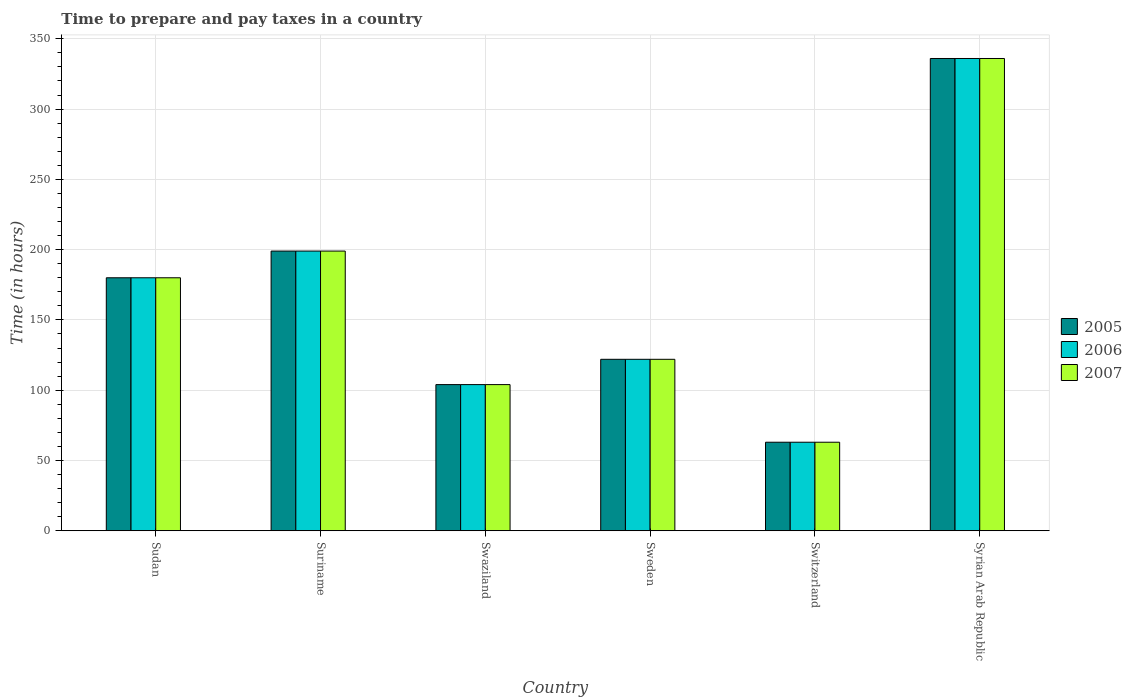Are the number of bars on each tick of the X-axis equal?
Offer a very short reply. Yes. What is the label of the 3rd group of bars from the left?
Provide a short and direct response. Swaziland. Across all countries, what is the maximum number of hours required to prepare and pay taxes in 2005?
Your response must be concise. 336. In which country was the number of hours required to prepare and pay taxes in 2007 maximum?
Offer a terse response. Syrian Arab Republic. In which country was the number of hours required to prepare and pay taxes in 2007 minimum?
Make the answer very short. Switzerland. What is the total number of hours required to prepare and pay taxes in 2006 in the graph?
Give a very brief answer. 1004. What is the difference between the number of hours required to prepare and pay taxes in 2007 in Sudan and that in Sweden?
Provide a succinct answer. 58. What is the difference between the number of hours required to prepare and pay taxes in 2005 in Swaziland and the number of hours required to prepare and pay taxes in 2007 in Suriname?
Ensure brevity in your answer.  -95. What is the average number of hours required to prepare and pay taxes in 2006 per country?
Provide a succinct answer. 167.33. In how many countries, is the number of hours required to prepare and pay taxes in 2007 greater than 340 hours?
Your answer should be compact. 0. What is the ratio of the number of hours required to prepare and pay taxes in 2005 in Sudan to that in Syrian Arab Republic?
Give a very brief answer. 0.54. Is the number of hours required to prepare and pay taxes in 2007 in Sweden less than that in Syrian Arab Republic?
Provide a succinct answer. Yes. What is the difference between the highest and the second highest number of hours required to prepare and pay taxes in 2005?
Offer a terse response. 156. What is the difference between the highest and the lowest number of hours required to prepare and pay taxes in 2006?
Keep it short and to the point. 273. In how many countries, is the number of hours required to prepare and pay taxes in 2005 greater than the average number of hours required to prepare and pay taxes in 2005 taken over all countries?
Your response must be concise. 3. What does the 3rd bar from the left in Sweden represents?
Ensure brevity in your answer.  2007. What does the 1st bar from the right in Swaziland represents?
Offer a terse response. 2007. Is it the case that in every country, the sum of the number of hours required to prepare and pay taxes in 2006 and number of hours required to prepare and pay taxes in 2007 is greater than the number of hours required to prepare and pay taxes in 2005?
Your answer should be very brief. Yes. How many bars are there?
Make the answer very short. 18. Are all the bars in the graph horizontal?
Give a very brief answer. No. How many countries are there in the graph?
Offer a very short reply. 6. Are the values on the major ticks of Y-axis written in scientific E-notation?
Provide a succinct answer. No. Does the graph contain any zero values?
Provide a short and direct response. No. Where does the legend appear in the graph?
Ensure brevity in your answer.  Center right. How many legend labels are there?
Offer a very short reply. 3. What is the title of the graph?
Provide a succinct answer. Time to prepare and pay taxes in a country. What is the label or title of the Y-axis?
Provide a succinct answer. Time (in hours). What is the Time (in hours) of 2005 in Sudan?
Ensure brevity in your answer.  180. What is the Time (in hours) in 2006 in Sudan?
Your answer should be very brief. 180. What is the Time (in hours) of 2007 in Sudan?
Provide a short and direct response. 180. What is the Time (in hours) of 2005 in Suriname?
Give a very brief answer. 199. What is the Time (in hours) of 2006 in Suriname?
Provide a succinct answer. 199. What is the Time (in hours) in 2007 in Suriname?
Give a very brief answer. 199. What is the Time (in hours) in 2005 in Swaziland?
Keep it short and to the point. 104. What is the Time (in hours) in 2006 in Swaziland?
Give a very brief answer. 104. What is the Time (in hours) of 2007 in Swaziland?
Offer a terse response. 104. What is the Time (in hours) in 2005 in Sweden?
Your answer should be very brief. 122. What is the Time (in hours) of 2006 in Sweden?
Keep it short and to the point. 122. What is the Time (in hours) in 2007 in Sweden?
Your answer should be very brief. 122. What is the Time (in hours) in 2005 in Switzerland?
Provide a succinct answer. 63. What is the Time (in hours) in 2007 in Switzerland?
Offer a very short reply. 63. What is the Time (in hours) of 2005 in Syrian Arab Republic?
Offer a terse response. 336. What is the Time (in hours) in 2006 in Syrian Arab Republic?
Provide a succinct answer. 336. What is the Time (in hours) in 2007 in Syrian Arab Republic?
Offer a terse response. 336. Across all countries, what is the maximum Time (in hours) of 2005?
Make the answer very short. 336. Across all countries, what is the maximum Time (in hours) of 2006?
Offer a very short reply. 336. Across all countries, what is the maximum Time (in hours) in 2007?
Make the answer very short. 336. Across all countries, what is the minimum Time (in hours) in 2005?
Give a very brief answer. 63. Across all countries, what is the minimum Time (in hours) in 2006?
Offer a very short reply. 63. Across all countries, what is the minimum Time (in hours) in 2007?
Offer a terse response. 63. What is the total Time (in hours) of 2005 in the graph?
Give a very brief answer. 1004. What is the total Time (in hours) of 2006 in the graph?
Keep it short and to the point. 1004. What is the total Time (in hours) in 2007 in the graph?
Ensure brevity in your answer.  1004. What is the difference between the Time (in hours) of 2006 in Sudan and that in Suriname?
Keep it short and to the point. -19. What is the difference between the Time (in hours) in 2005 in Sudan and that in Sweden?
Keep it short and to the point. 58. What is the difference between the Time (in hours) in 2007 in Sudan and that in Sweden?
Your answer should be very brief. 58. What is the difference between the Time (in hours) of 2005 in Sudan and that in Switzerland?
Your response must be concise. 117. What is the difference between the Time (in hours) in 2006 in Sudan and that in Switzerland?
Your response must be concise. 117. What is the difference between the Time (in hours) of 2007 in Sudan and that in Switzerland?
Your response must be concise. 117. What is the difference between the Time (in hours) of 2005 in Sudan and that in Syrian Arab Republic?
Offer a terse response. -156. What is the difference between the Time (in hours) in 2006 in Sudan and that in Syrian Arab Republic?
Ensure brevity in your answer.  -156. What is the difference between the Time (in hours) of 2007 in Sudan and that in Syrian Arab Republic?
Give a very brief answer. -156. What is the difference between the Time (in hours) in 2006 in Suriname and that in Swaziland?
Your answer should be compact. 95. What is the difference between the Time (in hours) in 2005 in Suriname and that in Sweden?
Provide a short and direct response. 77. What is the difference between the Time (in hours) in 2006 in Suriname and that in Sweden?
Provide a succinct answer. 77. What is the difference between the Time (in hours) in 2007 in Suriname and that in Sweden?
Give a very brief answer. 77. What is the difference between the Time (in hours) in 2005 in Suriname and that in Switzerland?
Provide a succinct answer. 136. What is the difference between the Time (in hours) of 2006 in Suriname and that in Switzerland?
Your answer should be compact. 136. What is the difference between the Time (in hours) of 2007 in Suriname and that in Switzerland?
Your response must be concise. 136. What is the difference between the Time (in hours) of 2005 in Suriname and that in Syrian Arab Republic?
Provide a short and direct response. -137. What is the difference between the Time (in hours) in 2006 in Suriname and that in Syrian Arab Republic?
Give a very brief answer. -137. What is the difference between the Time (in hours) of 2007 in Suriname and that in Syrian Arab Republic?
Provide a short and direct response. -137. What is the difference between the Time (in hours) of 2006 in Swaziland and that in Sweden?
Ensure brevity in your answer.  -18. What is the difference between the Time (in hours) of 2006 in Swaziland and that in Switzerland?
Give a very brief answer. 41. What is the difference between the Time (in hours) in 2007 in Swaziland and that in Switzerland?
Ensure brevity in your answer.  41. What is the difference between the Time (in hours) in 2005 in Swaziland and that in Syrian Arab Republic?
Provide a short and direct response. -232. What is the difference between the Time (in hours) in 2006 in Swaziland and that in Syrian Arab Republic?
Make the answer very short. -232. What is the difference between the Time (in hours) in 2007 in Swaziland and that in Syrian Arab Republic?
Your answer should be compact. -232. What is the difference between the Time (in hours) of 2005 in Sweden and that in Switzerland?
Give a very brief answer. 59. What is the difference between the Time (in hours) in 2005 in Sweden and that in Syrian Arab Republic?
Your answer should be compact. -214. What is the difference between the Time (in hours) in 2006 in Sweden and that in Syrian Arab Republic?
Your answer should be very brief. -214. What is the difference between the Time (in hours) of 2007 in Sweden and that in Syrian Arab Republic?
Make the answer very short. -214. What is the difference between the Time (in hours) of 2005 in Switzerland and that in Syrian Arab Republic?
Provide a short and direct response. -273. What is the difference between the Time (in hours) of 2006 in Switzerland and that in Syrian Arab Republic?
Provide a short and direct response. -273. What is the difference between the Time (in hours) in 2007 in Switzerland and that in Syrian Arab Republic?
Make the answer very short. -273. What is the difference between the Time (in hours) in 2005 in Sudan and the Time (in hours) in 2006 in Suriname?
Your response must be concise. -19. What is the difference between the Time (in hours) of 2006 in Sudan and the Time (in hours) of 2007 in Suriname?
Offer a very short reply. -19. What is the difference between the Time (in hours) in 2005 in Sudan and the Time (in hours) in 2006 in Swaziland?
Keep it short and to the point. 76. What is the difference between the Time (in hours) of 2005 in Sudan and the Time (in hours) of 2007 in Swaziland?
Give a very brief answer. 76. What is the difference between the Time (in hours) in 2006 in Sudan and the Time (in hours) in 2007 in Swaziland?
Offer a terse response. 76. What is the difference between the Time (in hours) in 2005 in Sudan and the Time (in hours) in 2007 in Sweden?
Keep it short and to the point. 58. What is the difference between the Time (in hours) in 2005 in Sudan and the Time (in hours) in 2006 in Switzerland?
Offer a terse response. 117. What is the difference between the Time (in hours) in 2005 in Sudan and the Time (in hours) in 2007 in Switzerland?
Keep it short and to the point. 117. What is the difference between the Time (in hours) in 2006 in Sudan and the Time (in hours) in 2007 in Switzerland?
Give a very brief answer. 117. What is the difference between the Time (in hours) in 2005 in Sudan and the Time (in hours) in 2006 in Syrian Arab Republic?
Offer a very short reply. -156. What is the difference between the Time (in hours) in 2005 in Sudan and the Time (in hours) in 2007 in Syrian Arab Republic?
Your answer should be very brief. -156. What is the difference between the Time (in hours) of 2006 in Sudan and the Time (in hours) of 2007 in Syrian Arab Republic?
Ensure brevity in your answer.  -156. What is the difference between the Time (in hours) of 2005 in Suriname and the Time (in hours) of 2006 in Swaziland?
Your answer should be very brief. 95. What is the difference between the Time (in hours) in 2006 in Suriname and the Time (in hours) in 2007 in Swaziland?
Your answer should be very brief. 95. What is the difference between the Time (in hours) of 2005 in Suriname and the Time (in hours) of 2007 in Sweden?
Your answer should be very brief. 77. What is the difference between the Time (in hours) in 2006 in Suriname and the Time (in hours) in 2007 in Sweden?
Ensure brevity in your answer.  77. What is the difference between the Time (in hours) in 2005 in Suriname and the Time (in hours) in 2006 in Switzerland?
Offer a very short reply. 136. What is the difference between the Time (in hours) of 2005 in Suriname and the Time (in hours) of 2007 in Switzerland?
Your response must be concise. 136. What is the difference between the Time (in hours) of 2006 in Suriname and the Time (in hours) of 2007 in Switzerland?
Provide a succinct answer. 136. What is the difference between the Time (in hours) of 2005 in Suriname and the Time (in hours) of 2006 in Syrian Arab Republic?
Your answer should be very brief. -137. What is the difference between the Time (in hours) in 2005 in Suriname and the Time (in hours) in 2007 in Syrian Arab Republic?
Your response must be concise. -137. What is the difference between the Time (in hours) in 2006 in Suriname and the Time (in hours) in 2007 in Syrian Arab Republic?
Your response must be concise. -137. What is the difference between the Time (in hours) of 2005 in Swaziland and the Time (in hours) of 2006 in Sweden?
Provide a short and direct response. -18. What is the difference between the Time (in hours) in 2005 in Swaziland and the Time (in hours) in 2007 in Sweden?
Provide a succinct answer. -18. What is the difference between the Time (in hours) of 2005 in Swaziland and the Time (in hours) of 2006 in Switzerland?
Provide a succinct answer. 41. What is the difference between the Time (in hours) of 2005 in Swaziland and the Time (in hours) of 2007 in Switzerland?
Offer a terse response. 41. What is the difference between the Time (in hours) of 2006 in Swaziland and the Time (in hours) of 2007 in Switzerland?
Offer a terse response. 41. What is the difference between the Time (in hours) of 2005 in Swaziland and the Time (in hours) of 2006 in Syrian Arab Republic?
Give a very brief answer. -232. What is the difference between the Time (in hours) of 2005 in Swaziland and the Time (in hours) of 2007 in Syrian Arab Republic?
Provide a short and direct response. -232. What is the difference between the Time (in hours) in 2006 in Swaziland and the Time (in hours) in 2007 in Syrian Arab Republic?
Keep it short and to the point. -232. What is the difference between the Time (in hours) of 2006 in Sweden and the Time (in hours) of 2007 in Switzerland?
Offer a very short reply. 59. What is the difference between the Time (in hours) in 2005 in Sweden and the Time (in hours) in 2006 in Syrian Arab Republic?
Offer a very short reply. -214. What is the difference between the Time (in hours) of 2005 in Sweden and the Time (in hours) of 2007 in Syrian Arab Republic?
Provide a short and direct response. -214. What is the difference between the Time (in hours) of 2006 in Sweden and the Time (in hours) of 2007 in Syrian Arab Republic?
Provide a short and direct response. -214. What is the difference between the Time (in hours) in 2005 in Switzerland and the Time (in hours) in 2006 in Syrian Arab Republic?
Offer a terse response. -273. What is the difference between the Time (in hours) of 2005 in Switzerland and the Time (in hours) of 2007 in Syrian Arab Republic?
Ensure brevity in your answer.  -273. What is the difference between the Time (in hours) of 2006 in Switzerland and the Time (in hours) of 2007 in Syrian Arab Republic?
Ensure brevity in your answer.  -273. What is the average Time (in hours) in 2005 per country?
Give a very brief answer. 167.33. What is the average Time (in hours) of 2006 per country?
Your answer should be very brief. 167.33. What is the average Time (in hours) in 2007 per country?
Your answer should be compact. 167.33. What is the difference between the Time (in hours) of 2005 and Time (in hours) of 2006 in Sudan?
Ensure brevity in your answer.  0. What is the difference between the Time (in hours) of 2005 and Time (in hours) of 2007 in Suriname?
Your answer should be compact. 0. What is the difference between the Time (in hours) of 2005 and Time (in hours) of 2007 in Swaziland?
Your response must be concise. 0. What is the difference between the Time (in hours) of 2005 and Time (in hours) of 2006 in Switzerland?
Your answer should be very brief. 0. What is the difference between the Time (in hours) in 2006 and Time (in hours) in 2007 in Syrian Arab Republic?
Your response must be concise. 0. What is the ratio of the Time (in hours) of 2005 in Sudan to that in Suriname?
Your answer should be very brief. 0.9. What is the ratio of the Time (in hours) in 2006 in Sudan to that in Suriname?
Your answer should be compact. 0.9. What is the ratio of the Time (in hours) of 2007 in Sudan to that in Suriname?
Make the answer very short. 0.9. What is the ratio of the Time (in hours) of 2005 in Sudan to that in Swaziland?
Offer a terse response. 1.73. What is the ratio of the Time (in hours) of 2006 in Sudan to that in Swaziland?
Keep it short and to the point. 1.73. What is the ratio of the Time (in hours) in 2007 in Sudan to that in Swaziland?
Give a very brief answer. 1.73. What is the ratio of the Time (in hours) of 2005 in Sudan to that in Sweden?
Your response must be concise. 1.48. What is the ratio of the Time (in hours) of 2006 in Sudan to that in Sweden?
Provide a succinct answer. 1.48. What is the ratio of the Time (in hours) of 2007 in Sudan to that in Sweden?
Make the answer very short. 1.48. What is the ratio of the Time (in hours) of 2005 in Sudan to that in Switzerland?
Offer a terse response. 2.86. What is the ratio of the Time (in hours) of 2006 in Sudan to that in Switzerland?
Provide a succinct answer. 2.86. What is the ratio of the Time (in hours) in 2007 in Sudan to that in Switzerland?
Your answer should be compact. 2.86. What is the ratio of the Time (in hours) in 2005 in Sudan to that in Syrian Arab Republic?
Provide a succinct answer. 0.54. What is the ratio of the Time (in hours) in 2006 in Sudan to that in Syrian Arab Republic?
Give a very brief answer. 0.54. What is the ratio of the Time (in hours) of 2007 in Sudan to that in Syrian Arab Republic?
Make the answer very short. 0.54. What is the ratio of the Time (in hours) of 2005 in Suriname to that in Swaziland?
Your answer should be very brief. 1.91. What is the ratio of the Time (in hours) in 2006 in Suriname to that in Swaziland?
Give a very brief answer. 1.91. What is the ratio of the Time (in hours) in 2007 in Suriname to that in Swaziland?
Your response must be concise. 1.91. What is the ratio of the Time (in hours) of 2005 in Suriname to that in Sweden?
Offer a very short reply. 1.63. What is the ratio of the Time (in hours) in 2006 in Suriname to that in Sweden?
Your answer should be very brief. 1.63. What is the ratio of the Time (in hours) in 2007 in Suriname to that in Sweden?
Give a very brief answer. 1.63. What is the ratio of the Time (in hours) of 2005 in Suriname to that in Switzerland?
Your answer should be compact. 3.16. What is the ratio of the Time (in hours) in 2006 in Suriname to that in Switzerland?
Keep it short and to the point. 3.16. What is the ratio of the Time (in hours) of 2007 in Suriname to that in Switzerland?
Your answer should be very brief. 3.16. What is the ratio of the Time (in hours) of 2005 in Suriname to that in Syrian Arab Republic?
Ensure brevity in your answer.  0.59. What is the ratio of the Time (in hours) of 2006 in Suriname to that in Syrian Arab Republic?
Your response must be concise. 0.59. What is the ratio of the Time (in hours) of 2007 in Suriname to that in Syrian Arab Republic?
Offer a very short reply. 0.59. What is the ratio of the Time (in hours) in 2005 in Swaziland to that in Sweden?
Your answer should be very brief. 0.85. What is the ratio of the Time (in hours) of 2006 in Swaziland to that in Sweden?
Your response must be concise. 0.85. What is the ratio of the Time (in hours) in 2007 in Swaziland to that in Sweden?
Give a very brief answer. 0.85. What is the ratio of the Time (in hours) in 2005 in Swaziland to that in Switzerland?
Keep it short and to the point. 1.65. What is the ratio of the Time (in hours) in 2006 in Swaziland to that in Switzerland?
Offer a very short reply. 1.65. What is the ratio of the Time (in hours) in 2007 in Swaziland to that in Switzerland?
Provide a succinct answer. 1.65. What is the ratio of the Time (in hours) of 2005 in Swaziland to that in Syrian Arab Republic?
Your response must be concise. 0.31. What is the ratio of the Time (in hours) in 2006 in Swaziland to that in Syrian Arab Republic?
Keep it short and to the point. 0.31. What is the ratio of the Time (in hours) of 2007 in Swaziland to that in Syrian Arab Republic?
Keep it short and to the point. 0.31. What is the ratio of the Time (in hours) of 2005 in Sweden to that in Switzerland?
Provide a succinct answer. 1.94. What is the ratio of the Time (in hours) of 2006 in Sweden to that in Switzerland?
Ensure brevity in your answer.  1.94. What is the ratio of the Time (in hours) of 2007 in Sweden to that in Switzerland?
Your response must be concise. 1.94. What is the ratio of the Time (in hours) of 2005 in Sweden to that in Syrian Arab Republic?
Your answer should be compact. 0.36. What is the ratio of the Time (in hours) of 2006 in Sweden to that in Syrian Arab Republic?
Your answer should be compact. 0.36. What is the ratio of the Time (in hours) in 2007 in Sweden to that in Syrian Arab Republic?
Ensure brevity in your answer.  0.36. What is the ratio of the Time (in hours) of 2005 in Switzerland to that in Syrian Arab Republic?
Your answer should be very brief. 0.19. What is the ratio of the Time (in hours) of 2006 in Switzerland to that in Syrian Arab Republic?
Provide a short and direct response. 0.19. What is the ratio of the Time (in hours) of 2007 in Switzerland to that in Syrian Arab Republic?
Offer a terse response. 0.19. What is the difference between the highest and the second highest Time (in hours) of 2005?
Your answer should be very brief. 137. What is the difference between the highest and the second highest Time (in hours) of 2006?
Give a very brief answer. 137. What is the difference between the highest and the second highest Time (in hours) of 2007?
Ensure brevity in your answer.  137. What is the difference between the highest and the lowest Time (in hours) in 2005?
Provide a succinct answer. 273. What is the difference between the highest and the lowest Time (in hours) of 2006?
Give a very brief answer. 273. What is the difference between the highest and the lowest Time (in hours) in 2007?
Provide a short and direct response. 273. 